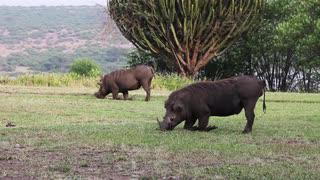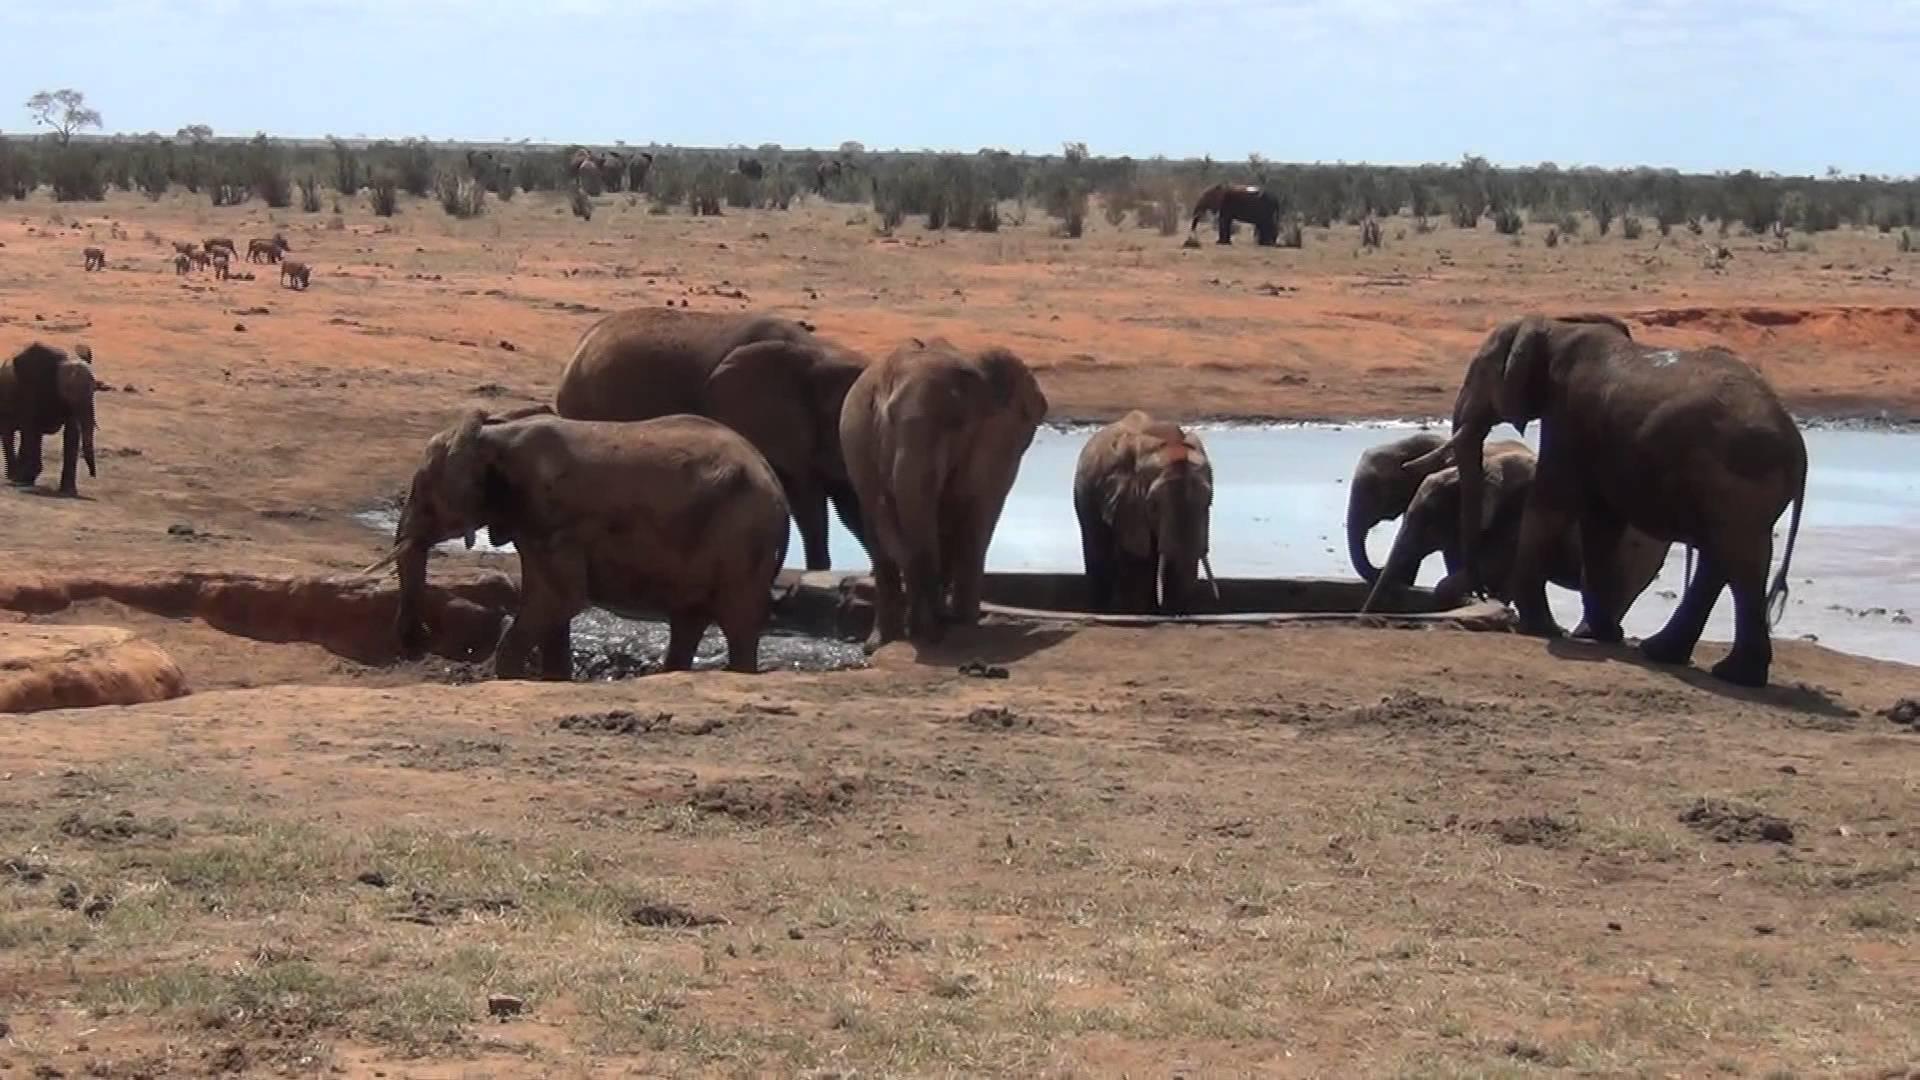The first image is the image on the left, the second image is the image on the right. Assess this claim about the two images: "There is at least one hog facing left.". Correct or not? Answer yes or no. Yes. The first image is the image on the left, the second image is the image on the right. Assess this claim about the two images: "there is only one adult animal in the image on the left". Correct or not? Answer yes or no. No. 